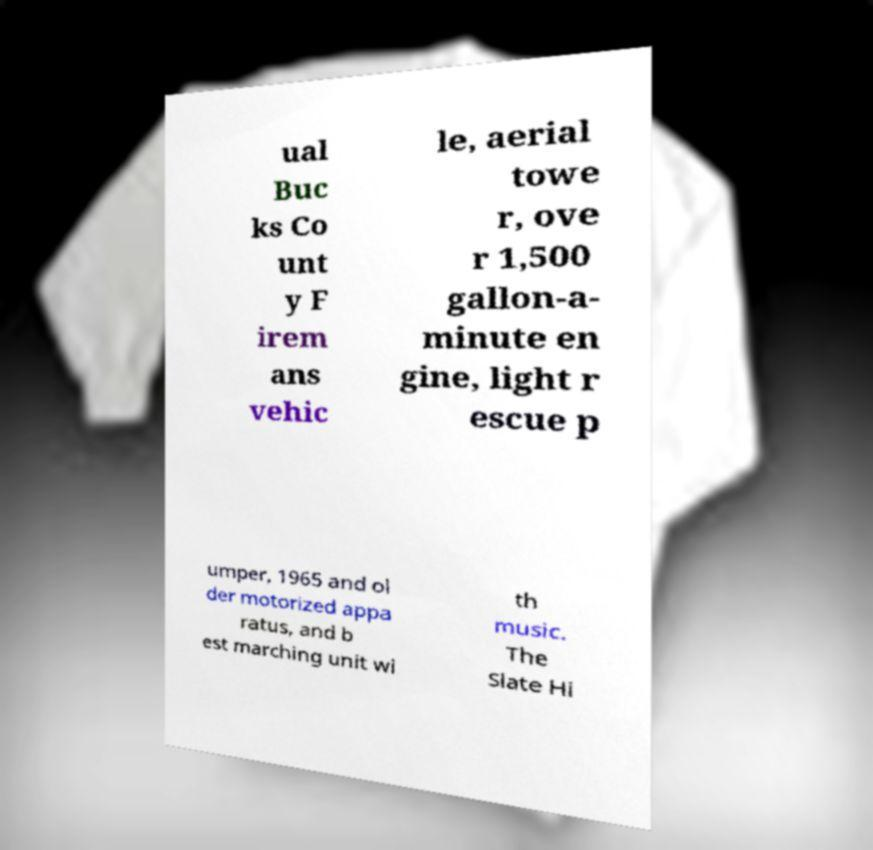Please identify and transcribe the text found in this image. ual Buc ks Co unt y F irem ans vehic le, aerial towe r, ove r 1,500 gallon-a- minute en gine, light r escue p umper, 1965 and ol der motorized appa ratus, and b est marching unit wi th music. The Slate Hi 